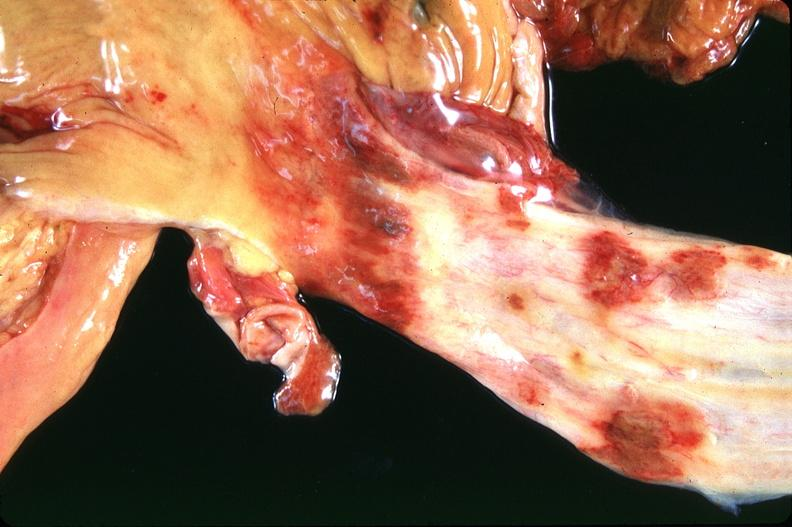what is present?
Answer the question using a single word or phrase. Gastrointestinal 